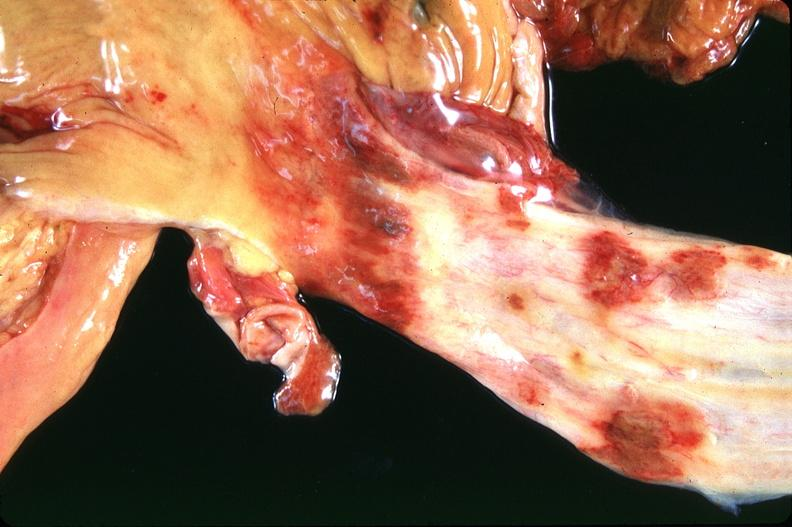what is present?
Answer the question using a single word or phrase. Gastrointestinal 